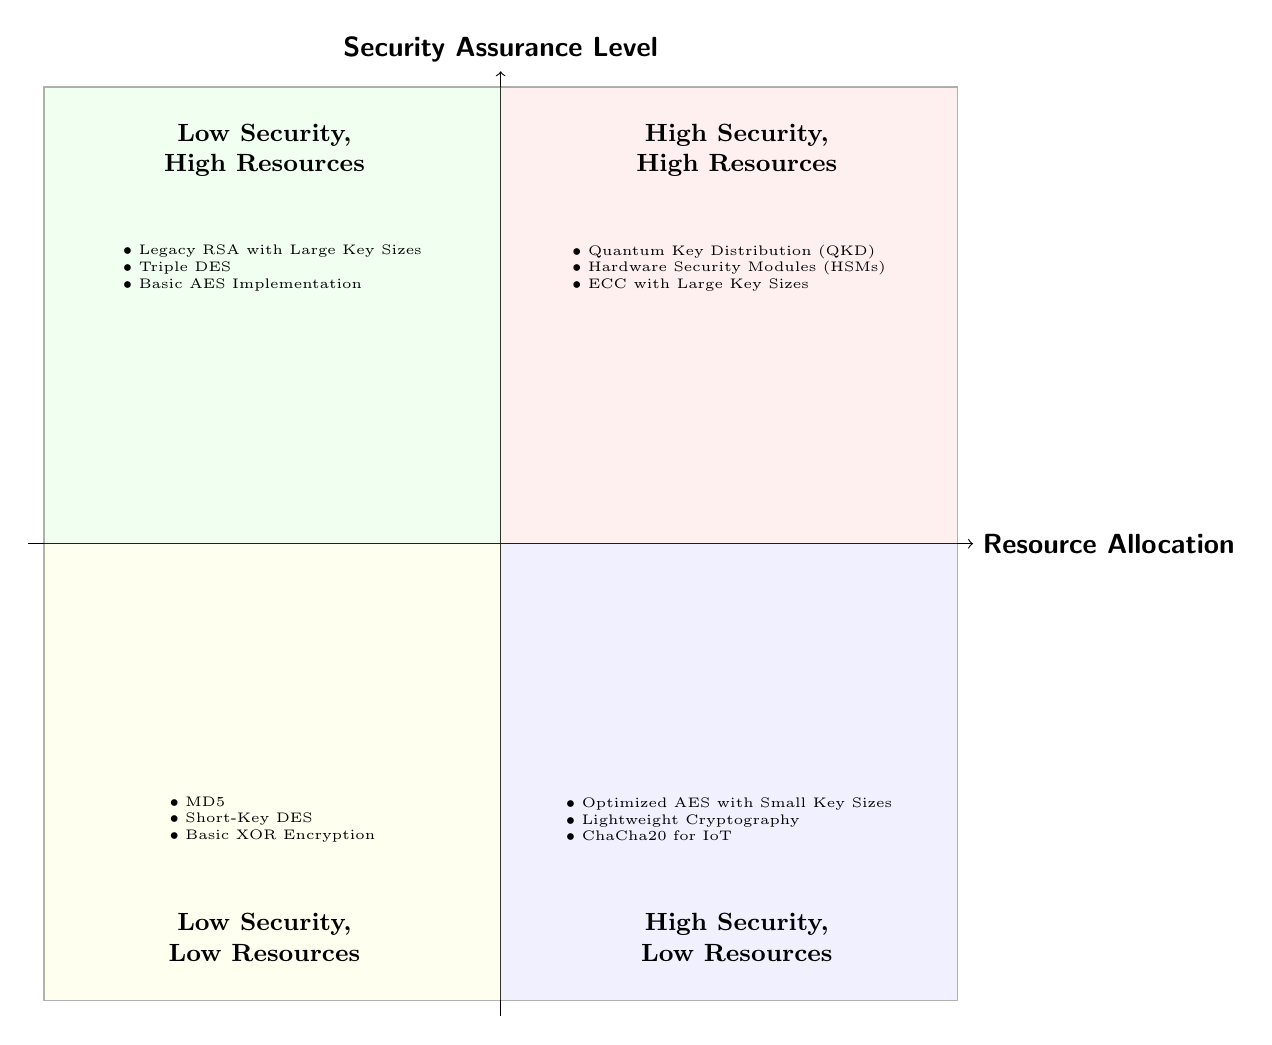What is in the High Security, High Resources quadrant? This quadrant contains examples of cryptographic systems that prioritize both security and resource allocation. The examples listed are Quantum Key Distribution (QKD), Hardware Security Modules (HSMs), and Elliptic Curve Cryptography (ECC) with Large Key Sizes.
Answer: Quantum Key Distribution (QKD), Hardware Security Modules (HSMs), ECC with Large Key Sizes How many quadrants are in the diagram? The diagram is divided into four distinct quadrants, each representing different combinations of security assurance levels and resource allocation.
Answer: 4 Which quadrant includes Lightweight Cryptography? Lightweight Cryptography is listed in the High Security, Low Resources quadrant. This quadrant indicates systems that are secure yet require fewer resources.
Answer: High Security, Low Resources What encryption method is found in the Low Security, High Resources quadrant? In this quadrant, one of the examples is Legacy RSA with Large Key Sizes. This illustrates a situation where high resources are allocated, but the security level is low.
Answer: Legacy RSA with Large Key Sizes Which quadrant contains Basic XOR Encryption? Basic XOR Encryption is found in the Low Security, Low Resources quadrant. This indicates that the method offers low security and uses minimal resources.
Answer: Low Security, Low Resources What is the common characteristic of the High Security, Low Resources quadrant? The common characteristic of this quadrant is that it consists of cryptographic systems that provide a high level of security while requiring lower resource allocation, such as Optimized AES with Small Key Sizes.
Answer: High level of security and lower resources How does the security assurance level change when moving from Low Security to High Security in the quadrants? As we move from the Low Security quadrants to the High Security quadrants, the examples provided generally reflect increasing complexity and strength of the cryptographic methods employed.
Answer: Increasing complexity and strength Name a cryptographic method categorized under Low Security, High Resources. An example of a cryptographic method in the Low Security, High Resources quadrant is Triple DES, which is known for its higher resource demand but lower security.
Answer: Triple DES 